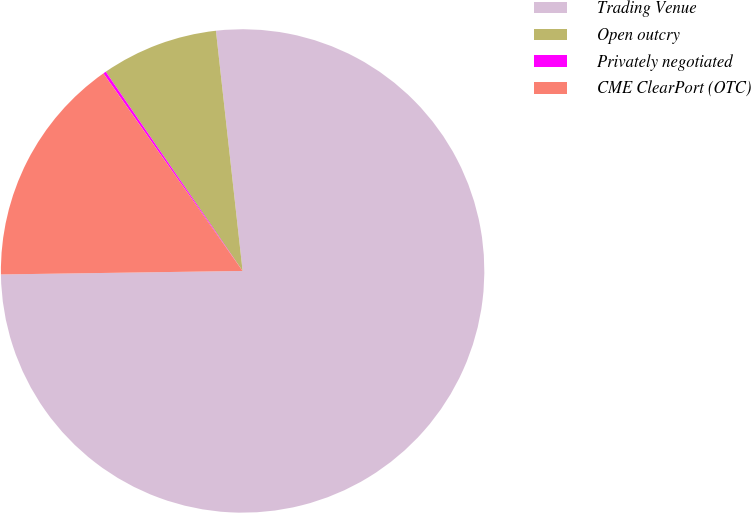<chart> <loc_0><loc_0><loc_500><loc_500><pie_chart><fcel>Trading Venue<fcel>Open outcry<fcel>Privately negotiated<fcel>CME ClearPort (OTC)<nl><fcel>76.53%<fcel>7.82%<fcel>0.19%<fcel>15.46%<nl></chart> 